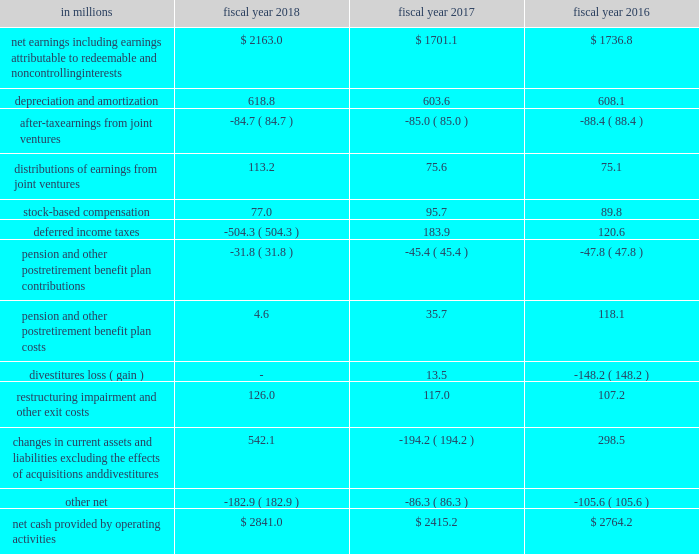Cash flows from operations .
In fiscal 2018 , cash provided by operations was $ 2.8 billion compared to $ 2.4 billion in fiscal 2017 .
The $ 426 million increase was primarily driven by the $ 462 million increase in net earnings and the $ 736 million change in current assets and liabilities , partially offset by a $ 688 million change in deferred income taxes .
The change in deferred income taxes was primarily related to the $ 638 million provisional benefit from revaluing our net u.s .
Deferred tax liabilities to reflect the new u.s .
Corporate tax rate as a result of the tcja .
The $ 736 million change in current assets and liabilities was primarily due to changes in accounts payable of $ 476 million related to the extension of payment terms and timing of payments , and $ 264 million of changes in other current liabilities primarily driven by changes in income taxes payable , trade and advertising accruals , and incentive accruals .
We strive to grow core working capital at or below the rate of growth in our net sales .
For fiscal 2018 , core working capital decreased 27 percent , compared to a net sales increase of 1 percent .
In fiscal 2017 , core working capital increased 9 percent , compared to a net sales decline of 6 percent , and in fiscal 2016 , core working capital decreased 41 percent , compared to net sales decline of 6 percent .
In fiscal 2017 , our operations generated $ 2.4 billion of cash , compared to $ 2.8 billion in fiscal 2016 .
The $ 349 million decrease was primarily driven by a $ 493 million change in current assets and liabilities .
The $ 493 million change in current assets and liabilities was primarily due to changes in other current liabilities driven by changes in income taxes payable , a decrease in incentive accruals , and changes in trade and advertising accruals due to reduced spending .
The change in current assets and liabilities was also impacted by the timing of accounts payable .
Additionally , we recorded a $ 14 million loss on a divestiture during fiscal 2017 , compared to a $ 148 million net gain on divestitures during fiscal 2016 , and classified the related cash flows as investing activities. .
What was the percent of the change in the cash provided by operations from 2017 to 2018\\n? 
Computations: ((2.8 - 2.4) / 2.4)
Answer: 0.16667. 